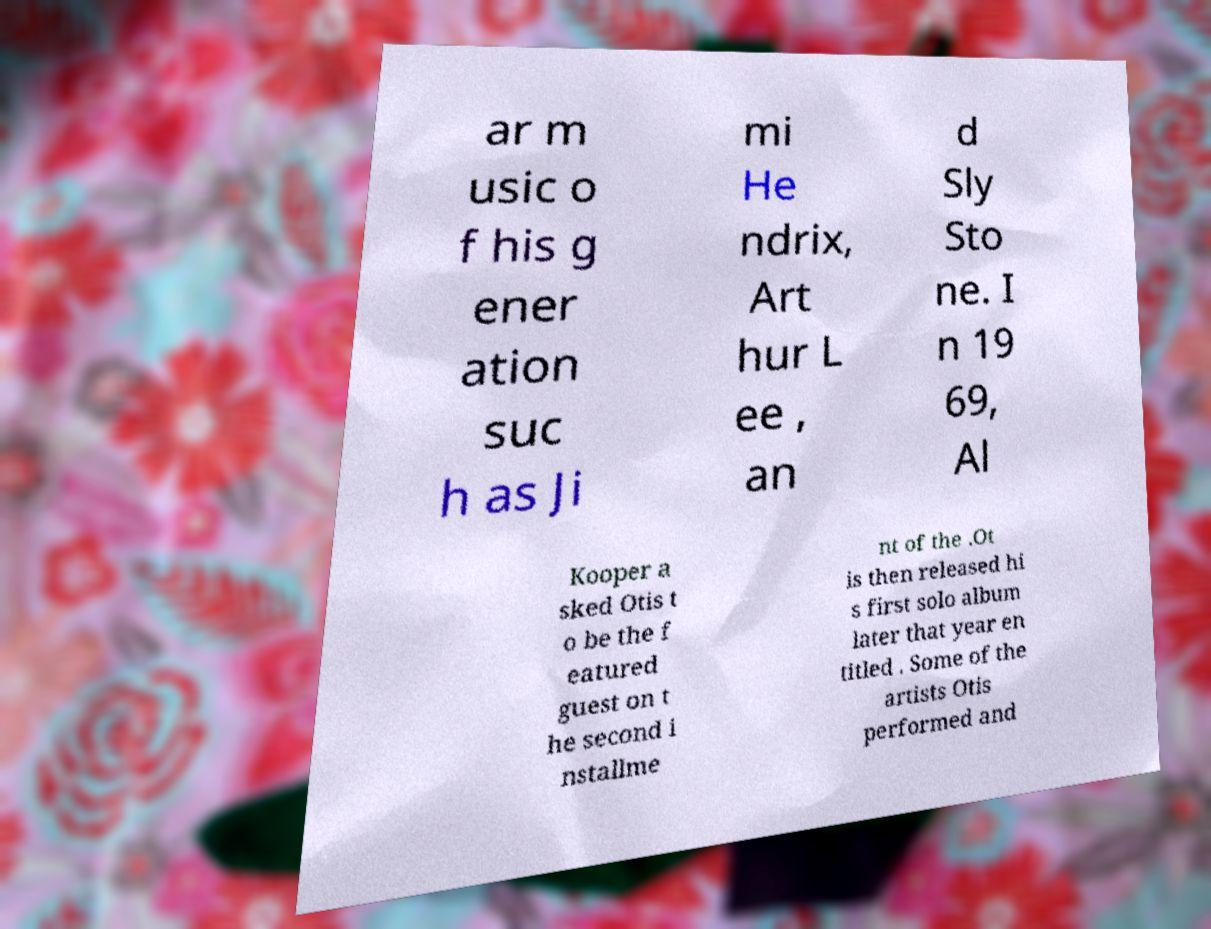What messages or text are displayed in this image? I need them in a readable, typed format. ar m usic o f his g ener ation suc h as Ji mi He ndrix, Art hur L ee , an d Sly Sto ne. I n 19 69, Al Kooper a sked Otis t o be the f eatured guest on t he second i nstallme nt of the .Ot is then released hi s first solo album later that year en titled . Some of the artists Otis performed and 